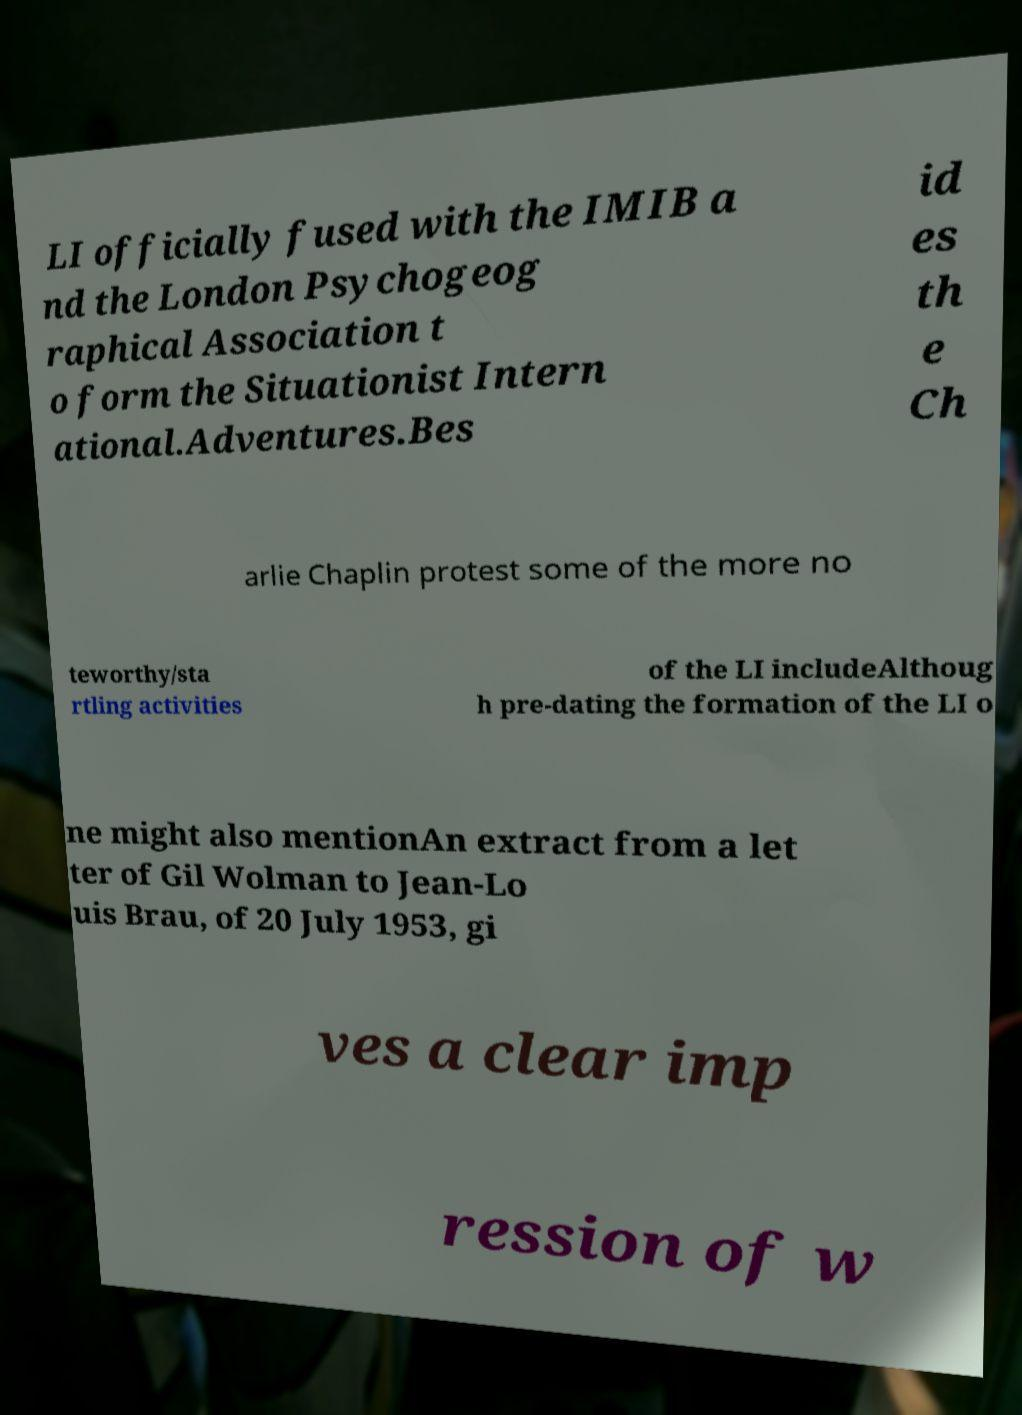Can you read and provide the text displayed in the image?This photo seems to have some interesting text. Can you extract and type it out for me? LI officially fused with the IMIB a nd the London Psychogeog raphical Association t o form the Situationist Intern ational.Adventures.Bes id es th e Ch arlie Chaplin protest some of the more no teworthy/sta rtling activities of the LI includeAlthoug h pre-dating the formation of the LI o ne might also mentionAn extract from a let ter of Gil Wolman to Jean-Lo uis Brau, of 20 July 1953, gi ves a clear imp ression of w 